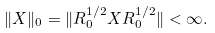Convert formula to latex. <formula><loc_0><loc_0><loc_500><loc_500>\| X \| _ { 0 } = \| R _ { 0 } ^ { 1 / 2 } X R _ { 0 } ^ { 1 / 2 } \| < \infty .</formula> 